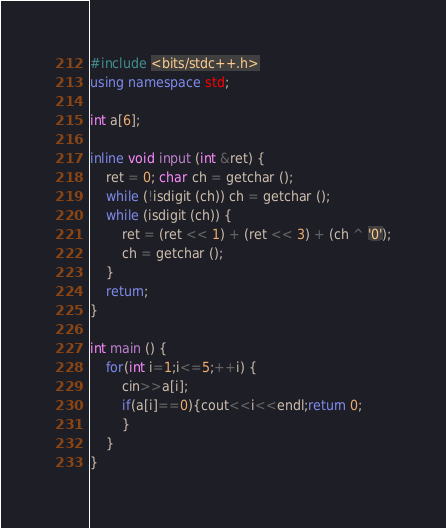<code> <loc_0><loc_0><loc_500><loc_500><_C++_>#include <bits/stdc++.h>
using namespace std;

int a[6];

inline void input (int &ret) {
	ret = 0; char ch = getchar ();
	while (!isdigit (ch)) ch = getchar ();
	while (isdigit (ch)) {
		ret = (ret << 1) + (ret << 3) + (ch ^ '0');
		ch = getchar ();
	}
	return;
}

int main () {
	for(int i=1;i<=5;++i) {
		cin>>a[i];
		if(a[i]==0){cout<<i<<endl;return 0;
		}
	}
}</code> 